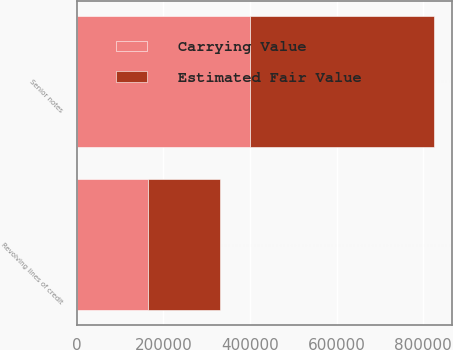Convert chart. <chart><loc_0><loc_0><loc_500><loc_500><stacked_bar_chart><ecel><fcel>Revolving lines of credit<fcel>Senior notes<nl><fcel>Carrying Value<fcel>165000<fcel>400000<nl><fcel>Estimated Fair Value<fcel>165000<fcel>424399<nl></chart> 